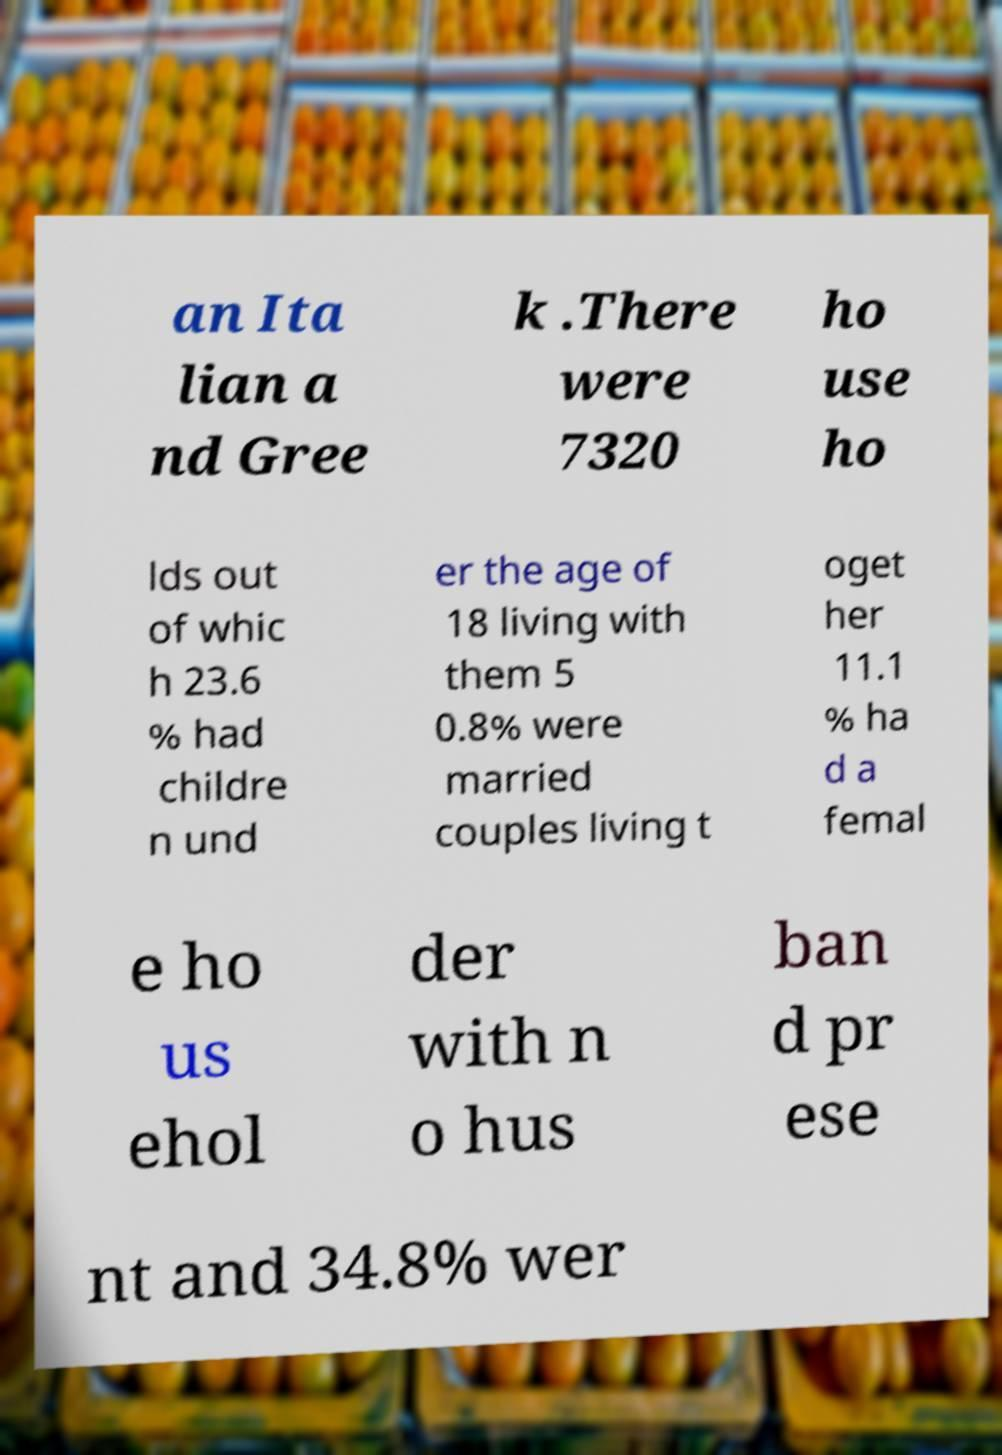Can you read and provide the text displayed in the image?This photo seems to have some interesting text. Can you extract and type it out for me? an Ita lian a nd Gree k .There were 7320 ho use ho lds out of whic h 23.6 % had childre n und er the age of 18 living with them 5 0.8% were married couples living t oget her 11.1 % ha d a femal e ho us ehol der with n o hus ban d pr ese nt and 34.8% wer 